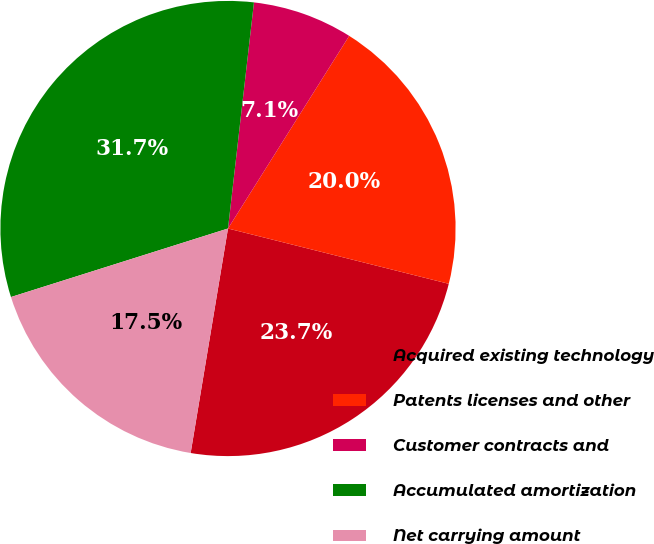<chart> <loc_0><loc_0><loc_500><loc_500><pie_chart><fcel>Acquired existing technology<fcel>Patents licenses and other<fcel>Customer contracts and<fcel>Accumulated amortization<fcel>Net carrying amount<nl><fcel>23.72%<fcel>19.97%<fcel>7.12%<fcel>31.69%<fcel>17.51%<nl></chart> 